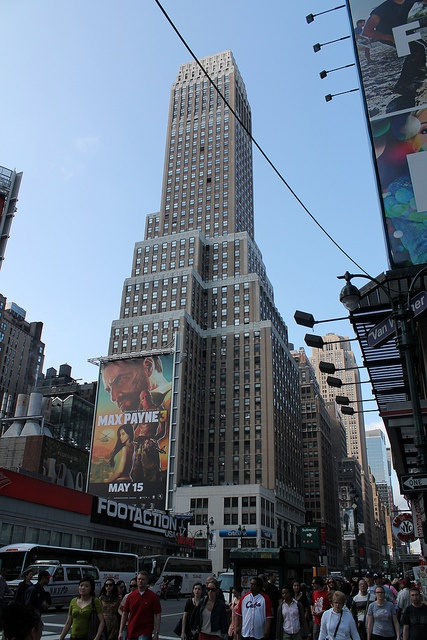Describe the objects in this image and their specific colors. I can see people in lightblue, black, gray, and darkgreen tones, bus in lightblue, black, gray, blue, and darkgray tones, people in lightblue, black, maroon, gray, and blue tones, bus in lightblue, black, gray, and blue tones, and people in lightblue, black, and gray tones in this image. 